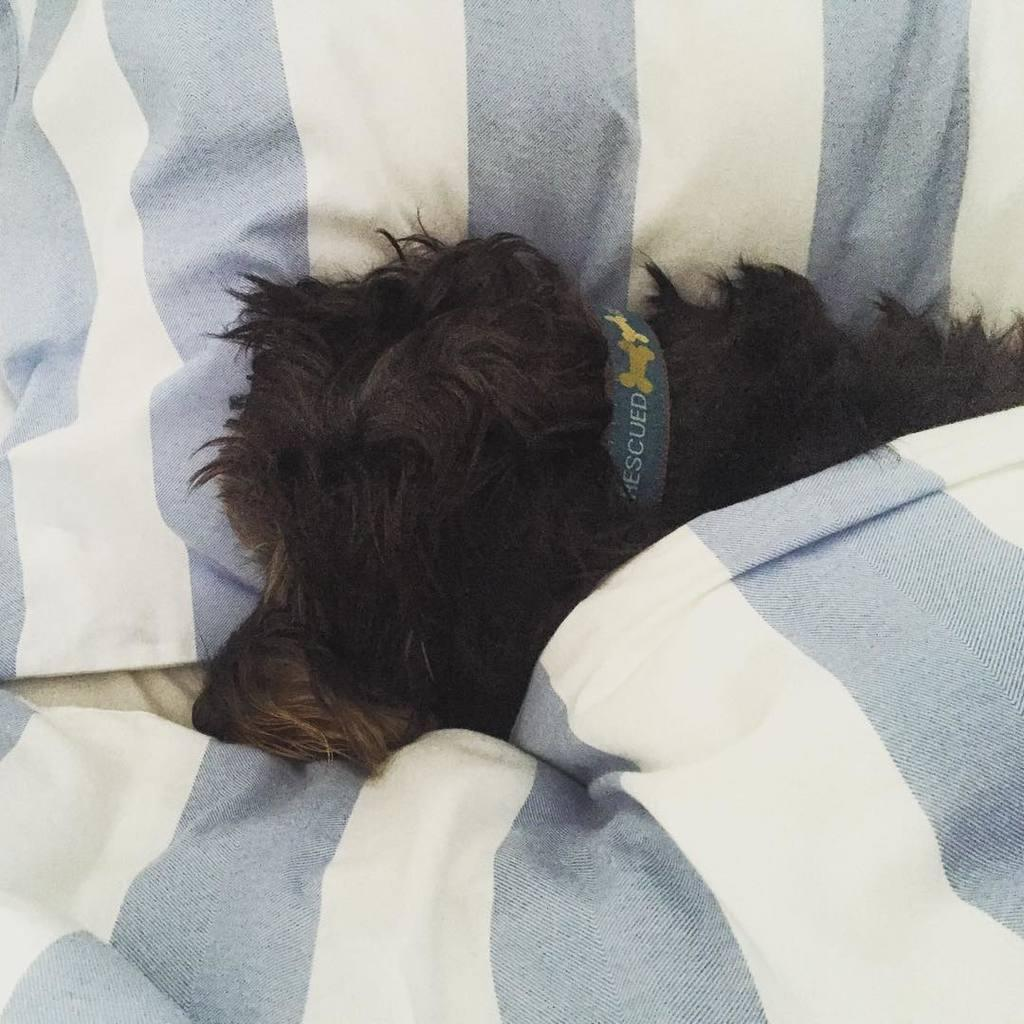What type of animal is present in the image? There is a dog in the image. What is the dog wearing? The dog is wearing a belt. What other items can be seen in the image? There is a bed sheet and a pillow in the image. What type of cloud can be seen in the image? There are no clouds present in the image; it features a dog wearing a belt, a bed sheet, and a pillow. 